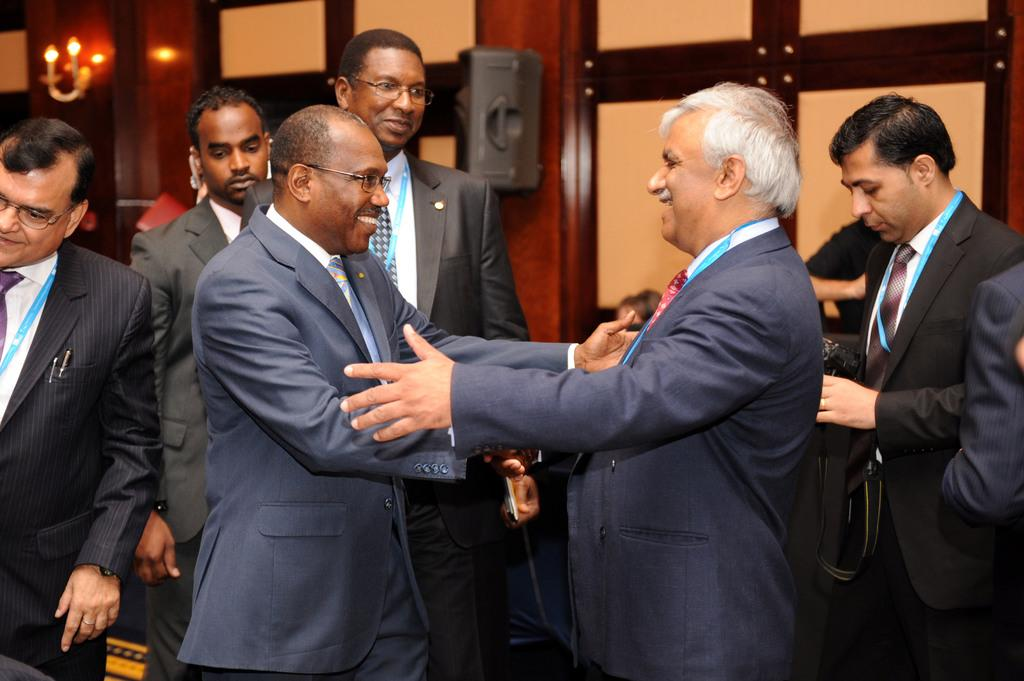How many people are smiling in the image? There are two persons standing and smiling in the image. What can be seen in the background of the image? There is a group of people standing, a person holding a camera, a speaker, a light, and a wall in the background of the image. What might the person holding a camera be doing? The person holding a camera might be taking a picture or recording a video. What is the purpose of the speaker in the background? The speaker might be used for amplifying sound during an event or presentation. Can you see a stream flowing behind the wall in the image? There is no stream visible in the image; it only shows a wall in the background. 